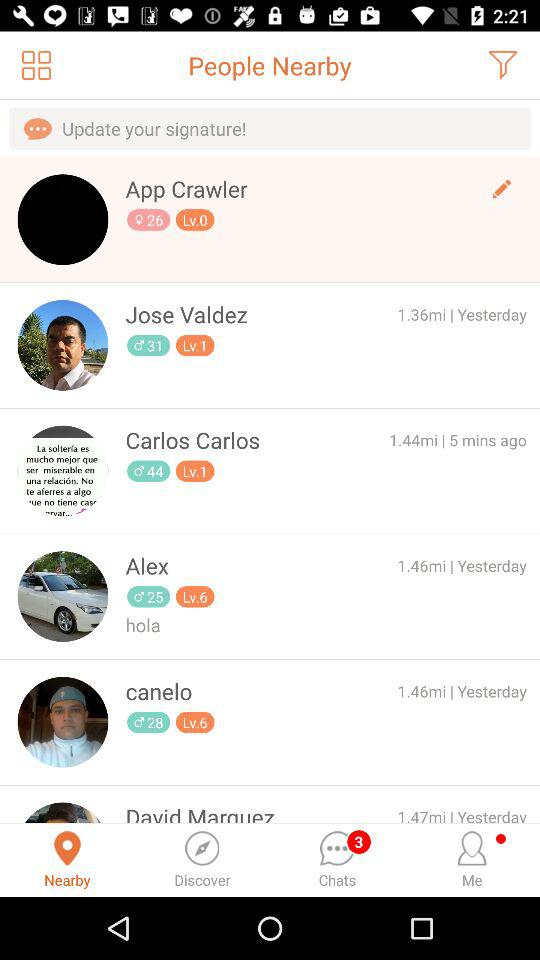At what level is Carlos? Carlos is at the first level. 